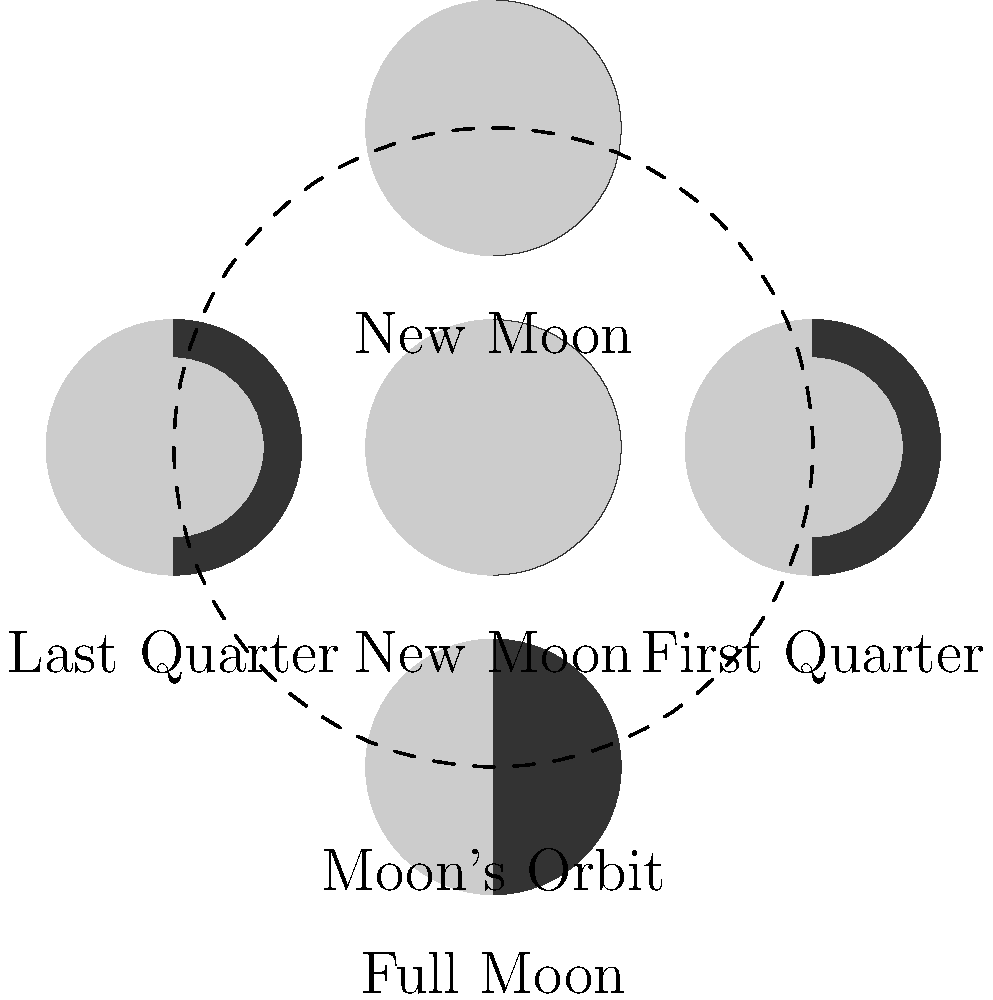During the championship match, you notice the moon is exactly half-illuminated. Based on the circular diagram of moon phases, what phase will the moon be in approximately one week later? To answer this question, let's follow these steps:

1. Identify the starting point: The question states that the moon is exactly half-illuminated, which corresponds to either the First Quarter or Last Quarter phase.

2. Determine the direction of progression: The moon's phases progress in a clockwise direction in the given diagram.

3. Locate the First Quarter moon: In the diagram, the First Quarter moon is shown on the right side, with the right half illuminated.

4. Count forward one week: Since the moon's cycle is approximately 29.5 days, one week represents about a quarter of its cycle.

5. Move one position clockwise: From the First Quarter position, moving one quarter of the way around the circle clockwise brings us to the Full Moon phase.

Therefore, approximately one week after observing a half-illuminated moon (assuming it's the First Quarter), the moon will be in the Full Moon phase.
Answer: Full Moon 